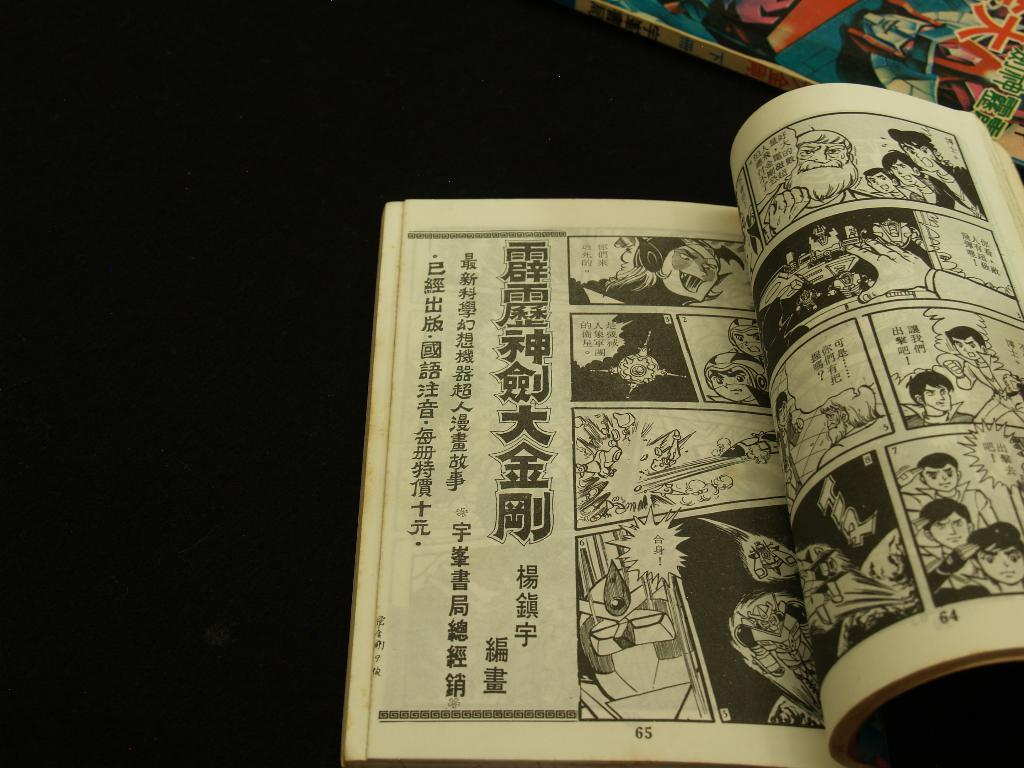<image>
Write a terse but informative summary of the picture. A comic book is open to page 65 is on a dark surface. 